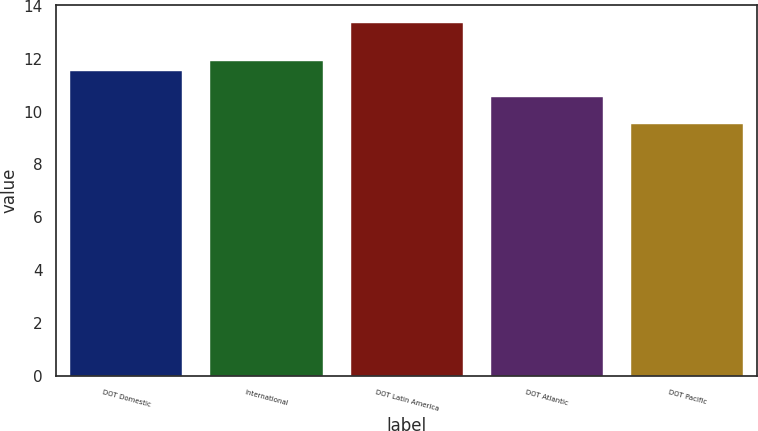<chart> <loc_0><loc_0><loc_500><loc_500><bar_chart><fcel>DOT Domestic<fcel>International<fcel>DOT Latin America<fcel>DOT Atlantic<fcel>DOT Pacific<nl><fcel>11.54<fcel>11.92<fcel>13.37<fcel>10.55<fcel>9.53<nl></chart> 